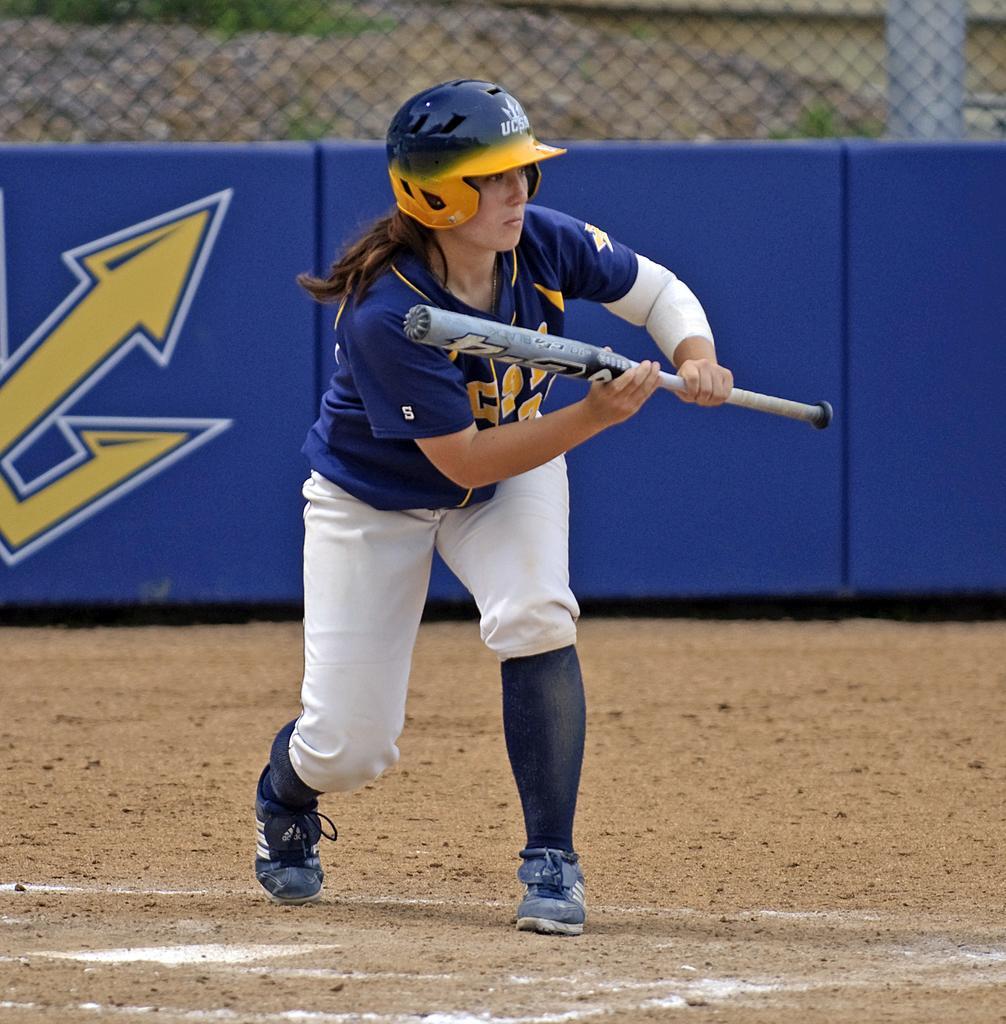Please provide a concise description of this image. In this image, we can see a woman is holding a bat and wearing a helmet. She is standing on the ground. Here we can see white lines. Background there is a banner, mesh, pole, few plants. 